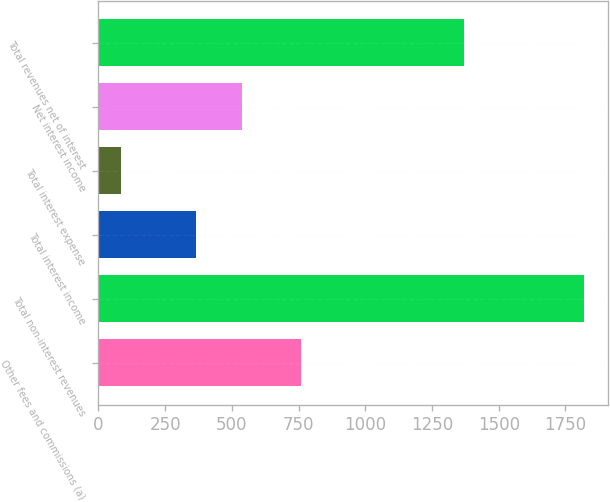<chart> <loc_0><loc_0><loc_500><loc_500><bar_chart><fcel>Other fees and commissions (a)<fcel>Total non-interest revenues<fcel>Total interest income<fcel>Total interest expense<fcel>Net interest income<fcel>Total revenues net of interest<nl><fcel>760<fcel>1820<fcel>366<fcel>84<fcel>539.6<fcel>1370<nl></chart> 